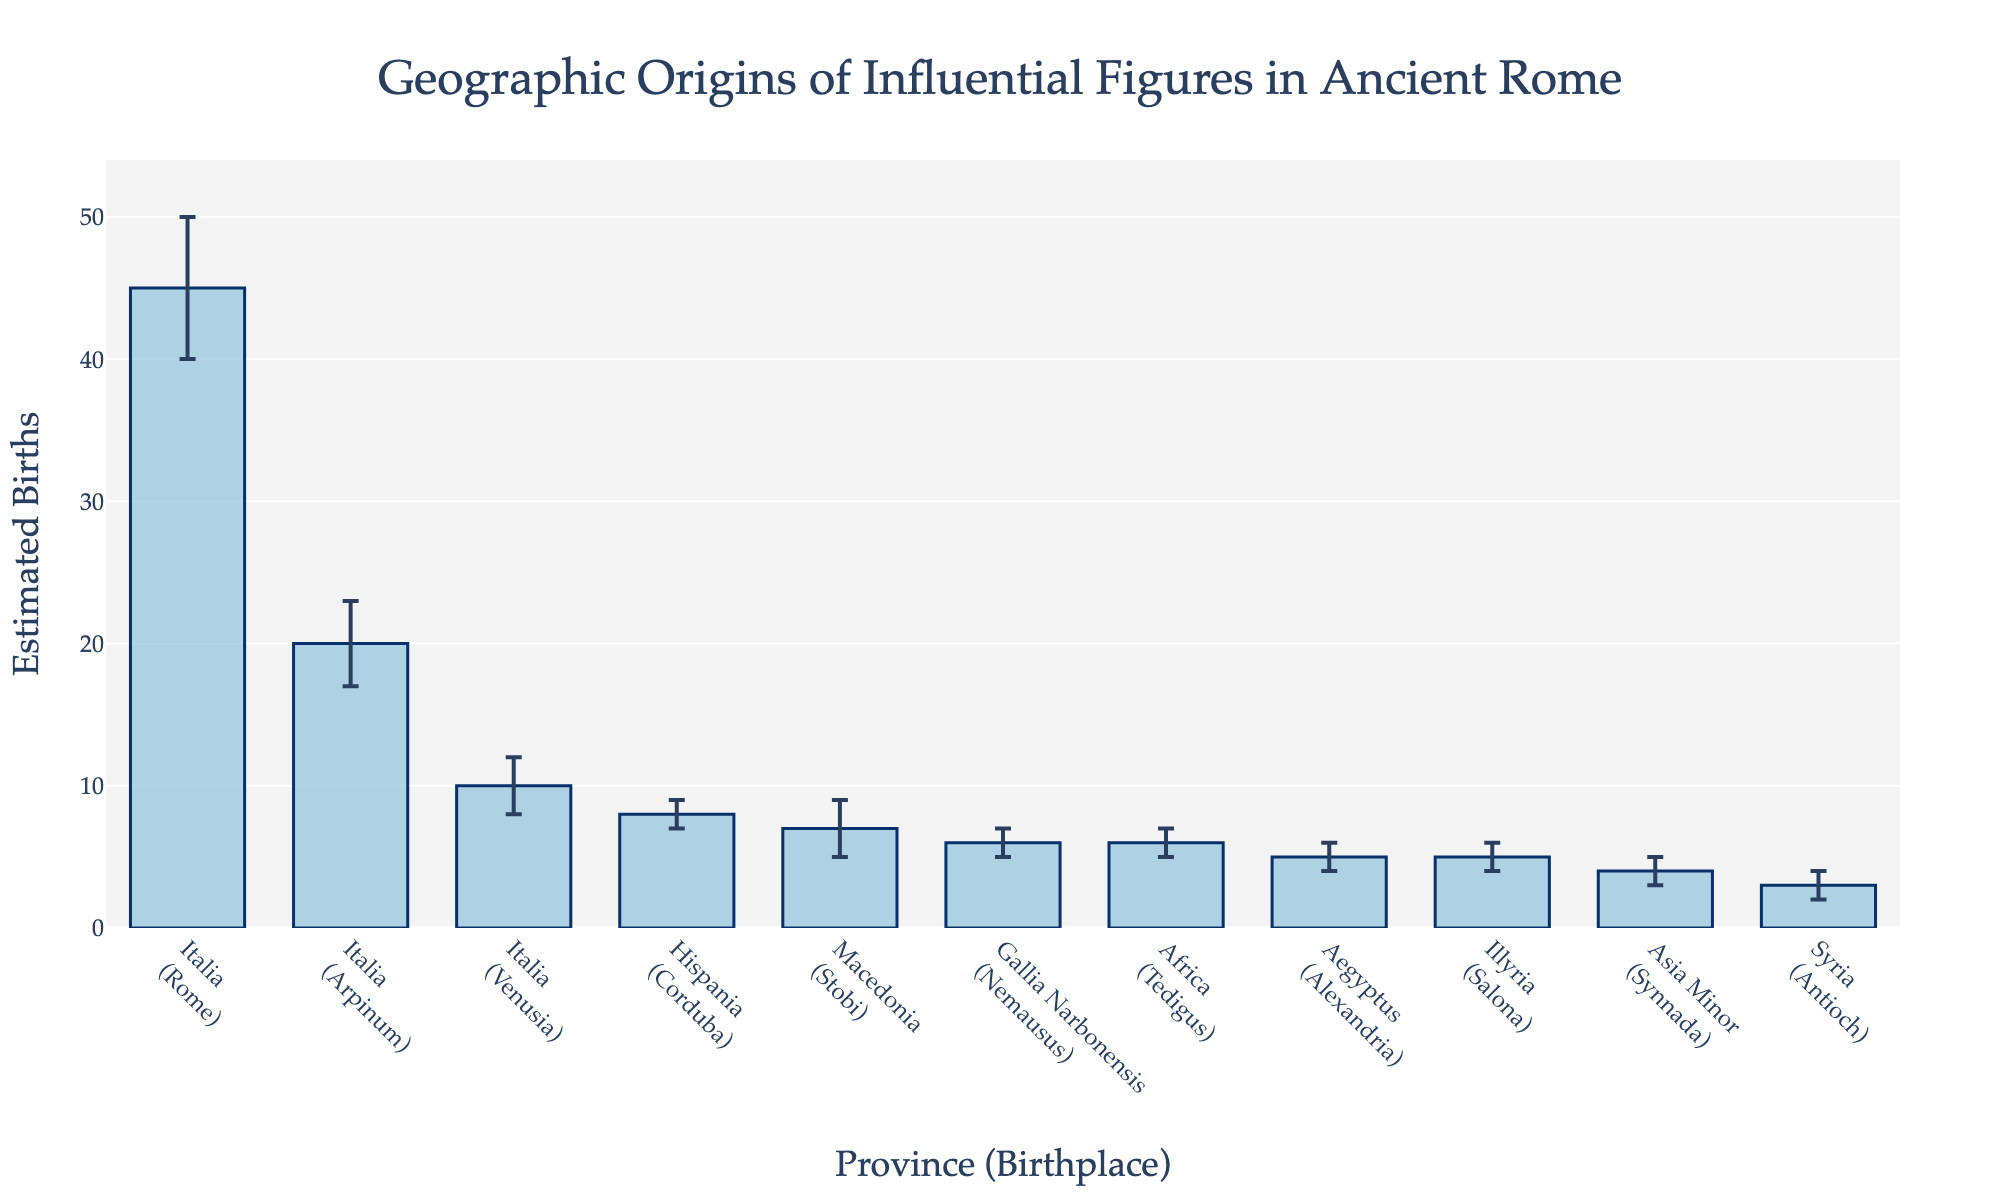How many influential figures were estimated to be born in Rome? By looking at the height of the bar corresponding to Rome in the "Italia" province, we see an estimated 45 births.
Answer: 45 Which birthplace has the smallest estimated number of influential figures? By examining the heights of all the bars, we find that "Antioch (Syria)" has the smallest estimated number at 3 births.
Answer: Antioch What is the sum of estimated births for all the birthplaces in the "Italia" province? Adding the estimated births from all the birthplaces in "Italia" (Rome, Arpinum, Venusia) gives us 45 + 20 + 10 = 75.
Answer: 75 How does the number of estimated births in Arpinum compare to that in Corduba? The bar for Arpinum has an estimated 20 births, while Corduba has 8. Therefore, Arpinum has more estimated births than Corduba.
Answer: Arpinum has more Which province has the highest overall estimated number of influential figure births? "Italia" has the highest number when combining the values for Rome, Arpinum, and Venusia. Summing these gives 75, which is higher than any other province's summed values.
Answer: Italia What's the total standard error for the birthplaces in "Italia"? Adding the standard errors for "Italia" province (5 from Rome, 3 from Arpinum, 2 from Venusia), we get 5 + 3 + 2 = 10.
Answer: 10 What is the estimated number of births in Nemausus, and what is its standard error? The bar corresponding to Nemausus in "Gallia Narbonensis" province shows an estimated 6 births with a standard error of 1.
Answer: 6 births, 1 standard error How many figures were estimated to be born outside Italia? Summing the bars for all provinces excluding Italia: 8 (Hispania) + 6 (Gallia Narbonensis) + 7 (Macedonia) + 5 (Aegyptus) + 4 (Asia Minor) + 3 (Syria) + 6 (Africa) + 5 (Illyria) = 44.
Answer: 44 Which influential figure's estimated birthplace has the largest standard error, and what is the value? By examining the error bars, we see that Julius Caesar's birthplace (Rome) has the largest standard error at 5.
Answer: Julius Caesar, 5 